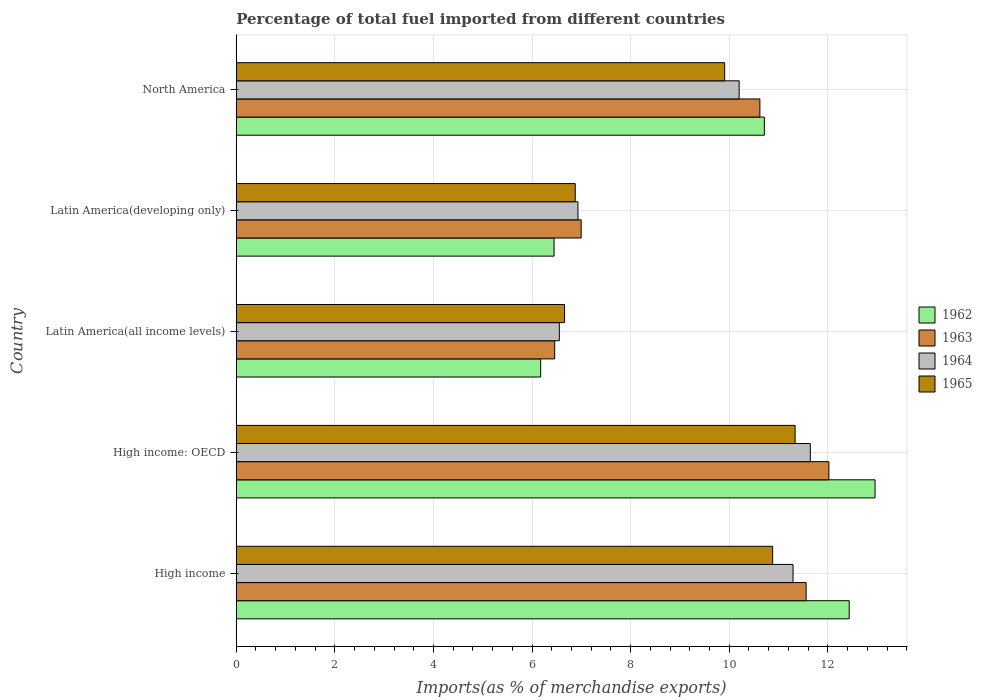How many different coloured bars are there?
Your answer should be very brief. 4. How many bars are there on the 2nd tick from the top?
Provide a short and direct response. 4. How many bars are there on the 1st tick from the bottom?
Provide a succinct answer. 4. In how many cases, is the number of bars for a given country not equal to the number of legend labels?
Offer a very short reply. 0. What is the percentage of imports to different countries in 1964 in North America?
Offer a terse response. 10.2. Across all countries, what is the maximum percentage of imports to different countries in 1965?
Give a very brief answer. 11.34. Across all countries, what is the minimum percentage of imports to different countries in 1962?
Ensure brevity in your answer.  6.17. In which country was the percentage of imports to different countries in 1962 maximum?
Give a very brief answer. High income: OECD. In which country was the percentage of imports to different countries in 1964 minimum?
Your answer should be very brief. Latin America(all income levels). What is the total percentage of imports to different countries in 1962 in the graph?
Keep it short and to the point. 48.72. What is the difference between the percentage of imports to different countries in 1964 in Latin America(developing only) and that in North America?
Make the answer very short. -3.27. What is the difference between the percentage of imports to different countries in 1962 in Latin America(all income levels) and the percentage of imports to different countries in 1965 in High income: OECD?
Your response must be concise. -5.16. What is the average percentage of imports to different countries in 1963 per country?
Provide a succinct answer. 9.53. What is the difference between the percentage of imports to different countries in 1965 and percentage of imports to different countries in 1964 in Latin America(all income levels)?
Keep it short and to the point. 0.11. In how many countries, is the percentage of imports to different countries in 1964 greater than 11.6 %?
Your answer should be compact. 1. What is the ratio of the percentage of imports to different countries in 1964 in High income to that in Latin America(developing only)?
Give a very brief answer. 1.63. Is the difference between the percentage of imports to different countries in 1965 in Latin America(all income levels) and North America greater than the difference between the percentage of imports to different countries in 1964 in Latin America(all income levels) and North America?
Offer a terse response. Yes. What is the difference between the highest and the second highest percentage of imports to different countries in 1962?
Offer a very short reply. 0.52. What is the difference between the highest and the lowest percentage of imports to different countries in 1962?
Provide a short and direct response. 6.78. In how many countries, is the percentage of imports to different countries in 1963 greater than the average percentage of imports to different countries in 1963 taken over all countries?
Keep it short and to the point. 3. Is the sum of the percentage of imports to different countries in 1964 in High income and Latin America(developing only) greater than the maximum percentage of imports to different countries in 1963 across all countries?
Your answer should be very brief. Yes. Is it the case that in every country, the sum of the percentage of imports to different countries in 1964 and percentage of imports to different countries in 1962 is greater than the sum of percentage of imports to different countries in 1965 and percentage of imports to different countries in 1963?
Ensure brevity in your answer.  No. What does the 4th bar from the top in Latin America(all income levels) represents?
Ensure brevity in your answer.  1962. Is it the case that in every country, the sum of the percentage of imports to different countries in 1963 and percentage of imports to different countries in 1962 is greater than the percentage of imports to different countries in 1964?
Your answer should be very brief. Yes. How many bars are there?
Your answer should be compact. 20. Are all the bars in the graph horizontal?
Offer a terse response. Yes. How many countries are there in the graph?
Make the answer very short. 5. Are the values on the major ticks of X-axis written in scientific E-notation?
Offer a terse response. No. Does the graph contain any zero values?
Ensure brevity in your answer.  No. Does the graph contain grids?
Ensure brevity in your answer.  Yes. Where does the legend appear in the graph?
Offer a very short reply. Center right. How many legend labels are there?
Make the answer very short. 4. What is the title of the graph?
Offer a very short reply. Percentage of total fuel imported from different countries. What is the label or title of the X-axis?
Give a very brief answer. Imports(as % of merchandise exports). What is the Imports(as % of merchandise exports) in 1962 in High income?
Offer a very short reply. 12.43. What is the Imports(as % of merchandise exports) of 1963 in High income?
Keep it short and to the point. 11.56. What is the Imports(as % of merchandise exports) in 1964 in High income?
Provide a succinct answer. 11.29. What is the Imports(as % of merchandise exports) in 1965 in High income?
Give a very brief answer. 10.88. What is the Imports(as % of merchandise exports) in 1962 in High income: OECD?
Your answer should be very brief. 12.96. What is the Imports(as % of merchandise exports) of 1963 in High income: OECD?
Provide a short and direct response. 12.02. What is the Imports(as % of merchandise exports) in 1964 in High income: OECD?
Offer a terse response. 11.64. What is the Imports(as % of merchandise exports) in 1965 in High income: OECD?
Provide a short and direct response. 11.34. What is the Imports(as % of merchandise exports) of 1962 in Latin America(all income levels)?
Ensure brevity in your answer.  6.17. What is the Imports(as % of merchandise exports) in 1963 in Latin America(all income levels)?
Your answer should be compact. 6.46. What is the Imports(as % of merchandise exports) in 1964 in Latin America(all income levels)?
Ensure brevity in your answer.  6.55. What is the Imports(as % of merchandise exports) in 1965 in Latin America(all income levels)?
Your answer should be compact. 6.66. What is the Imports(as % of merchandise exports) of 1962 in Latin America(developing only)?
Ensure brevity in your answer.  6.45. What is the Imports(as % of merchandise exports) of 1963 in Latin America(developing only)?
Offer a very short reply. 7. What is the Imports(as % of merchandise exports) in 1964 in Latin America(developing only)?
Make the answer very short. 6.93. What is the Imports(as % of merchandise exports) of 1965 in Latin America(developing only)?
Provide a succinct answer. 6.88. What is the Imports(as % of merchandise exports) of 1962 in North America?
Offer a very short reply. 10.71. What is the Imports(as % of merchandise exports) of 1963 in North America?
Offer a very short reply. 10.62. What is the Imports(as % of merchandise exports) of 1964 in North America?
Give a very brief answer. 10.2. What is the Imports(as % of merchandise exports) in 1965 in North America?
Offer a very short reply. 9.91. Across all countries, what is the maximum Imports(as % of merchandise exports) in 1962?
Ensure brevity in your answer.  12.96. Across all countries, what is the maximum Imports(as % of merchandise exports) in 1963?
Provide a succinct answer. 12.02. Across all countries, what is the maximum Imports(as % of merchandise exports) of 1964?
Provide a succinct answer. 11.64. Across all countries, what is the maximum Imports(as % of merchandise exports) of 1965?
Provide a short and direct response. 11.34. Across all countries, what is the minimum Imports(as % of merchandise exports) in 1962?
Give a very brief answer. 6.17. Across all countries, what is the minimum Imports(as % of merchandise exports) of 1963?
Offer a very short reply. 6.46. Across all countries, what is the minimum Imports(as % of merchandise exports) in 1964?
Provide a succinct answer. 6.55. Across all countries, what is the minimum Imports(as % of merchandise exports) in 1965?
Provide a short and direct response. 6.66. What is the total Imports(as % of merchandise exports) of 1962 in the graph?
Provide a short and direct response. 48.72. What is the total Imports(as % of merchandise exports) in 1963 in the graph?
Your answer should be compact. 47.66. What is the total Imports(as % of merchandise exports) in 1964 in the graph?
Provide a short and direct response. 46.62. What is the total Imports(as % of merchandise exports) of 1965 in the graph?
Give a very brief answer. 45.66. What is the difference between the Imports(as % of merchandise exports) of 1962 in High income and that in High income: OECD?
Offer a very short reply. -0.52. What is the difference between the Imports(as % of merchandise exports) of 1963 in High income and that in High income: OECD?
Provide a short and direct response. -0.46. What is the difference between the Imports(as % of merchandise exports) in 1964 in High income and that in High income: OECD?
Offer a very short reply. -0.35. What is the difference between the Imports(as % of merchandise exports) of 1965 in High income and that in High income: OECD?
Keep it short and to the point. -0.46. What is the difference between the Imports(as % of merchandise exports) in 1962 in High income and that in Latin America(all income levels)?
Your answer should be compact. 6.26. What is the difference between the Imports(as % of merchandise exports) of 1963 in High income and that in Latin America(all income levels)?
Provide a succinct answer. 5.1. What is the difference between the Imports(as % of merchandise exports) in 1964 in High income and that in Latin America(all income levels)?
Your response must be concise. 4.74. What is the difference between the Imports(as % of merchandise exports) of 1965 in High income and that in Latin America(all income levels)?
Provide a succinct answer. 4.22. What is the difference between the Imports(as % of merchandise exports) in 1962 in High income and that in Latin America(developing only)?
Give a very brief answer. 5.99. What is the difference between the Imports(as % of merchandise exports) in 1963 in High income and that in Latin America(developing only)?
Give a very brief answer. 4.56. What is the difference between the Imports(as % of merchandise exports) in 1964 in High income and that in Latin America(developing only)?
Provide a short and direct response. 4.36. What is the difference between the Imports(as % of merchandise exports) of 1965 in High income and that in Latin America(developing only)?
Give a very brief answer. 4. What is the difference between the Imports(as % of merchandise exports) of 1962 in High income and that in North America?
Offer a terse response. 1.72. What is the difference between the Imports(as % of merchandise exports) in 1963 in High income and that in North America?
Offer a very short reply. 0.94. What is the difference between the Imports(as % of merchandise exports) of 1964 in High income and that in North America?
Provide a short and direct response. 1.09. What is the difference between the Imports(as % of merchandise exports) of 1965 in High income and that in North America?
Your response must be concise. 0.97. What is the difference between the Imports(as % of merchandise exports) of 1962 in High income: OECD and that in Latin America(all income levels)?
Provide a short and direct response. 6.78. What is the difference between the Imports(as % of merchandise exports) of 1963 in High income: OECD and that in Latin America(all income levels)?
Provide a short and direct response. 5.56. What is the difference between the Imports(as % of merchandise exports) of 1964 in High income: OECD and that in Latin America(all income levels)?
Offer a very short reply. 5.09. What is the difference between the Imports(as % of merchandise exports) of 1965 in High income: OECD and that in Latin America(all income levels)?
Provide a succinct answer. 4.68. What is the difference between the Imports(as % of merchandise exports) in 1962 in High income: OECD and that in Latin America(developing only)?
Your answer should be compact. 6.51. What is the difference between the Imports(as % of merchandise exports) in 1963 in High income: OECD and that in Latin America(developing only)?
Offer a terse response. 5.02. What is the difference between the Imports(as % of merchandise exports) of 1964 in High income: OECD and that in Latin America(developing only)?
Your answer should be very brief. 4.71. What is the difference between the Imports(as % of merchandise exports) in 1965 in High income: OECD and that in Latin America(developing only)?
Offer a terse response. 4.46. What is the difference between the Imports(as % of merchandise exports) in 1962 in High income: OECD and that in North America?
Provide a short and direct response. 2.25. What is the difference between the Imports(as % of merchandise exports) in 1963 in High income: OECD and that in North America?
Provide a short and direct response. 1.4. What is the difference between the Imports(as % of merchandise exports) of 1964 in High income: OECD and that in North America?
Ensure brevity in your answer.  1.44. What is the difference between the Imports(as % of merchandise exports) in 1965 in High income: OECD and that in North America?
Ensure brevity in your answer.  1.43. What is the difference between the Imports(as % of merchandise exports) of 1962 in Latin America(all income levels) and that in Latin America(developing only)?
Your answer should be compact. -0.27. What is the difference between the Imports(as % of merchandise exports) in 1963 in Latin America(all income levels) and that in Latin America(developing only)?
Your response must be concise. -0.54. What is the difference between the Imports(as % of merchandise exports) in 1964 in Latin America(all income levels) and that in Latin America(developing only)?
Provide a short and direct response. -0.38. What is the difference between the Imports(as % of merchandise exports) of 1965 in Latin America(all income levels) and that in Latin America(developing only)?
Provide a succinct answer. -0.22. What is the difference between the Imports(as % of merchandise exports) in 1962 in Latin America(all income levels) and that in North America?
Give a very brief answer. -4.54. What is the difference between the Imports(as % of merchandise exports) in 1963 in Latin America(all income levels) and that in North America?
Offer a terse response. -4.16. What is the difference between the Imports(as % of merchandise exports) in 1964 in Latin America(all income levels) and that in North America?
Your response must be concise. -3.65. What is the difference between the Imports(as % of merchandise exports) in 1965 in Latin America(all income levels) and that in North America?
Offer a very short reply. -3.25. What is the difference between the Imports(as % of merchandise exports) in 1962 in Latin America(developing only) and that in North America?
Ensure brevity in your answer.  -4.27. What is the difference between the Imports(as % of merchandise exports) in 1963 in Latin America(developing only) and that in North America?
Your answer should be compact. -3.63. What is the difference between the Imports(as % of merchandise exports) in 1964 in Latin America(developing only) and that in North America?
Provide a short and direct response. -3.27. What is the difference between the Imports(as % of merchandise exports) in 1965 in Latin America(developing only) and that in North America?
Your answer should be compact. -3.03. What is the difference between the Imports(as % of merchandise exports) in 1962 in High income and the Imports(as % of merchandise exports) in 1963 in High income: OECD?
Offer a very short reply. 0.41. What is the difference between the Imports(as % of merchandise exports) of 1962 in High income and the Imports(as % of merchandise exports) of 1964 in High income: OECD?
Keep it short and to the point. 0.79. What is the difference between the Imports(as % of merchandise exports) of 1962 in High income and the Imports(as % of merchandise exports) of 1965 in High income: OECD?
Provide a succinct answer. 1.1. What is the difference between the Imports(as % of merchandise exports) in 1963 in High income and the Imports(as % of merchandise exports) in 1964 in High income: OECD?
Provide a short and direct response. -0.09. What is the difference between the Imports(as % of merchandise exports) in 1963 in High income and the Imports(as % of merchandise exports) in 1965 in High income: OECD?
Offer a terse response. 0.22. What is the difference between the Imports(as % of merchandise exports) of 1964 in High income and the Imports(as % of merchandise exports) of 1965 in High income: OECD?
Give a very brief answer. -0.04. What is the difference between the Imports(as % of merchandise exports) of 1962 in High income and the Imports(as % of merchandise exports) of 1963 in Latin America(all income levels)?
Provide a short and direct response. 5.97. What is the difference between the Imports(as % of merchandise exports) in 1962 in High income and the Imports(as % of merchandise exports) in 1964 in Latin America(all income levels)?
Your response must be concise. 5.88. What is the difference between the Imports(as % of merchandise exports) in 1962 in High income and the Imports(as % of merchandise exports) in 1965 in Latin America(all income levels)?
Offer a terse response. 5.77. What is the difference between the Imports(as % of merchandise exports) in 1963 in High income and the Imports(as % of merchandise exports) in 1964 in Latin America(all income levels)?
Your answer should be compact. 5.01. What is the difference between the Imports(as % of merchandise exports) of 1963 in High income and the Imports(as % of merchandise exports) of 1965 in Latin America(all income levels)?
Provide a short and direct response. 4.9. What is the difference between the Imports(as % of merchandise exports) in 1964 in High income and the Imports(as % of merchandise exports) in 1965 in Latin America(all income levels)?
Your answer should be very brief. 4.63. What is the difference between the Imports(as % of merchandise exports) of 1962 in High income and the Imports(as % of merchandise exports) of 1963 in Latin America(developing only)?
Ensure brevity in your answer.  5.44. What is the difference between the Imports(as % of merchandise exports) of 1962 in High income and the Imports(as % of merchandise exports) of 1964 in Latin America(developing only)?
Keep it short and to the point. 5.5. What is the difference between the Imports(as % of merchandise exports) of 1962 in High income and the Imports(as % of merchandise exports) of 1965 in Latin America(developing only)?
Ensure brevity in your answer.  5.56. What is the difference between the Imports(as % of merchandise exports) of 1963 in High income and the Imports(as % of merchandise exports) of 1964 in Latin America(developing only)?
Your answer should be very brief. 4.63. What is the difference between the Imports(as % of merchandise exports) of 1963 in High income and the Imports(as % of merchandise exports) of 1965 in Latin America(developing only)?
Ensure brevity in your answer.  4.68. What is the difference between the Imports(as % of merchandise exports) of 1964 in High income and the Imports(as % of merchandise exports) of 1965 in Latin America(developing only)?
Your answer should be compact. 4.42. What is the difference between the Imports(as % of merchandise exports) of 1962 in High income and the Imports(as % of merchandise exports) of 1963 in North America?
Provide a succinct answer. 1.81. What is the difference between the Imports(as % of merchandise exports) in 1962 in High income and the Imports(as % of merchandise exports) in 1964 in North America?
Your response must be concise. 2.23. What is the difference between the Imports(as % of merchandise exports) of 1962 in High income and the Imports(as % of merchandise exports) of 1965 in North America?
Provide a short and direct response. 2.53. What is the difference between the Imports(as % of merchandise exports) of 1963 in High income and the Imports(as % of merchandise exports) of 1964 in North America?
Provide a short and direct response. 1.36. What is the difference between the Imports(as % of merchandise exports) in 1963 in High income and the Imports(as % of merchandise exports) in 1965 in North America?
Provide a succinct answer. 1.65. What is the difference between the Imports(as % of merchandise exports) in 1964 in High income and the Imports(as % of merchandise exports) in 1965 in North America?
Give a very brief answer. 1.39. What is the difference between the Imports(as % of merchandise exports) of 1962 in High income: OECD and the Imports(as % of merchandise exports) of 1963 in Latin America(all income levels)?
Keep it short and to the point. 6.5. What is the difference between the Imports(as % of merchandise exports) of 1962 in High income: OECD and the Imports(as % of merchandise exports) of 1964 in Latin America(all income levels)?
Your response must be concise. 6.4. What is the difference between the Imports(as % of merchandise exports) in 1962 in High income: OECD and the Imports(as % of merchandise exports) in 1965 in Latin America(all income levels)?
Give a very brief answer. 6.3. What is the difference between the Imports(as % of merchandise exports) in 1963 in High income: OECD and the Imports(as % of merchandise exports) in 1964 in Latin America(all income levels)?
Make the answer very short. 5.47. What is the difference between the Imports(as % of merchandise exports) in 1963 in High income: OECD and the Imports(as % of merchandise exports) in 1965 in Latin America(all income levels)?
Keep it short and to the point. 5.36. What is the difference between the Imports(as % of merchandise exports) in 1964 in High income: OECD and the Imports(as % of merchandise exports) in 1965 in Latin America(all income levels)?
Your answer should be compact. 4.98. What is the difference between the Imports(as % of merchandise exports) of 1962 in High income: OECD and the Imports(as % of merchandise exports) of 1963 in Latin America(developing only)?
Make the answer very short. 5.96. What is the difference between the Imports(as % of merchandise exports) of 1962 in High income: OECD and the Imports(as % of merchandise exports) of 1964 in Latin America(developing only)?
Keep it short and to the point. 6.03. What is the difference between the Imports(as % of merchandise exports) in 1962 in High income: OECD and the Imports(as % of merchandise exports) in 1965 in Latin America(developing only)?
Ensure brevity in your answer.  6.08. What is the difference between the Imports(as % of merchandise exports) of 1963 in High income: OECD and the Imports(as % of merchandise exports) of 1964 in Latin America(developing only)?
Your response must be concise. 5.09. What is the difference between the Imports(as % of merchandise exports) of 1963 in High income: OECD and the Imports(as % of merchandise exports) of 1965 in Latin America(developing only)?
Your answer should be very brief. 5.15. What is the difference between the Imports(as % of merchandise exports) in 1964 in High income: OECD and the Imports(as % of merchandise exports) in 1965 in Latin America(developing only)?
Your answer should be very brief. 4.77. What is the difference between the Imports(as % of merchandise exports) of 1962 in High income: OECD and the Imports(as % of merchandise exports) of 1963 in North America?
Give a very brief answer. 2.34. What is the difference between the Imports(as % of merchandise exports) in 1962 in High income: OECD and the Imports(as % of merchandise exports) in 1964 in North America?
Give a very brief answer. 2.76. What is the difference between the Imports(as % of merchandise exports) in 1962 in High income: OECD and the Imports(as % of merchandise exports) in 1965 in North America?
Offer a terse response. 3.05. What is the difference between the Imports(as % of merchandise exports) in 1963 in High income: OECD and the Imports(as % of merchandise exports) in 1964 in North America?
Provide a succinct answer. 1.82. What is the difference between the Imports(as % of merchandise exports) of 1963 in High income: OECD and the Imports(as % of merchandise exports) of 1965 in North America?
Give a very brief answer. 2.11. What is the difference between the Imports(as % of merchandise exports) in 1964 in High income: OECD and the Imports(as % of merchandise exports) in 1965 in North America?
Make the answer very short. 1.74. What is the difference between the Imports(as % of merchandise exports) of 1962 in Latin America(all income levels) and the Imports(as % of merchandise exports) of 1963 in Latin America(developing only)?
Provide a succinct answer. -0.82. What is the difference between the Imports(as % of merchandise exports) of 1962 in Latin America(all income levels) and the Imports(as % of merchandise exports) of 1964 in Latin America(developing only)?
Your answer should be compact. -0.76. What is the difference between the Imports(as % of merchandise exports) of 1962 in Latin America(all income levels) and the Imports(as % of merchandise exports) of 1965 in Latin America(developing only)?
Provide a succinct answer. -0.7. What is the difference between the Imports(as % of merchandise exports) of 1963 in Latin America(all income levels) and the Imports(as % of merchandise exports) of 1964 in Latin America(developing only)?
Provide a short and direct response. -0.47. What is the difference between the Imports(as % of merchandise exports) in 1963 in Latin America(all income levels) and the Imports(as % of merchandise exports) in 1965 in Latin America(developing only)?
Offer a terse response. -0.42. What is the difference between the Imports(as % of merchandise exports) of 1964 in Latin America(all income levels) and the Imports(as % of merchandise exports) of 1965 in Latin America(developing only)?
Your answer should be compact. -0.32. What is the difference between the Imports(as % of merchandise exports) in 1962 in Latin America(all income levels) and the Imports(as % of merchandise exports) in 1963 in North America?
Offer a very short reply. -4.45. What is the difference between the Imports(as % of merchandise exports) of 1962 in Latin America(all income levels) and the Imports(as % of merchandise exports) of 1964 in North America?
Ensure brevity in your answer.  -4.03. What is the difference between the Imports(as % of merchandise exports) of 1962 in Latin America(all income levels) and the Imports(as % of merchandise exports) of 1965 in North America?
Offer a very short reply. -3.73. What is the difference between the Imports(as % of merchandise exports) in 1963 in Latin America(all income levels) and the Imports(as % of merchandise exports) in 1964 in North America?
Make the answer very short. -3.74. What is the difference between the Imports(as % of merchandise exports) in 1963 in Latin America(all income levels) and the Imports(as % of merchandise exports) in 1965 in North America?
Your answer should be very brief. -3.45. What is the difference between the Imports(as % of merchandise exports) in 1964 in Latin America(all income levels) and the Imports(as % of merchandise exports) in 1965 in North America?
Provide a short and direct response. -3.35. What is the difference between the Imports(as % of merchandise exports) of 1962 in Latin America(developing only) and the Imports(as % of merchandise exports) of 1963 in North America?
Provide a succinct answer. -4.17. What is the difference between the Imports(as % of merchandise exports) in 1962 in Latin America(developing only) and the Imports(as % of merchandise exports) in 1964 in North America?
Provide a short and direct response. -3.75. What is the difference between the Imports(as % of merchandise exports) in 1962 in Latin America(developing only) and the Imports(as % of merchandise exports) in 1965 in North America?
Offer a very short reply. -3.46. What is the difference between the Imports(as % of merchandise exports) in 1963 in Latin America(developing only) and the Imports(as % of merchandise exports) in 1964 in North America?
Give a very brief answer. -3.2. What is the difference between the Imports(as % of merchandise exports) in 1963 in Latin America(developing only) and the Imports(as % of merchandise exports) in 1965 in North America?
Offer a very short reply. -2.91. What is the difference between the Imports(as % of merchandise exports) in 1964 in Latin America(developing only) and the Imports(as % of merchandise exports) in 1965 in North America?
Make the answer very short. -2.98. What is the average Imports(as % of merchandise exports) in 1962 per country?
Make the answer very short. 9.74. What is the average Imports(as % of merchandise exports) in 1963 per country?
Provide a short and direct response. 9.53. What is the average Imports(as % of merchandise exports) of 1964 per country?
Your answer should be very brief. 9.32. What is the average Imports(as % of merchandise exports) of 1965 per country?
Provide a short and direct response. 9.13. What is the difference between the Imports(as % of merchandise exports) of 1962 and Imports(as % of merchandise exports) of 1963 in High income?
Your answer should be compact. 0.87. What is the difference between the Imports(as % of merchandise exports) of 1962 and Imports(as % of merchandise exports) of 1964 in High income?
Ensure brevity in your answer.  1.14. What is the difference between the Imports(as % of merchandise exports) in 1962 and Imports(as % of merchandise exports) in 1965 in High income?
Give a very brief answer. 1.55. What is the difference between the Imports(as % of merchandise exports) in 1963 and Imports(as % of merchandise exports) in 1964 in High income?
Ensure brevity in your answer.  0.27. What is the difference between the Imports(as % of merchandise exports) in 1963 and Imports(as % of merchandise exports) in 1965 in High income?
Offer a very short reply. 0.68. What is the difference between the Imports(as % of merchandise exports) of 1964 and Imports(as % of merchandise exports) of 1965 in High income?
Your response must be concise. 0.41. What is the difference between the Imports(as % of merchandise exports) in 1962 and Imports(as % of merchandise exports) in 1963 in High income: OECD?
Offer a terse response. 0.94. What is the difference between the Imports(as % of merchandise exports) in 1962 and Imports(as % of merchandise exports) in 1964 in High income: OECD?
Your answer should be compact. 1.31. What is the difference between the Imports(as % of merchandise exports) of 1962 and Imports(as % of merchandise exports) of 1965 in High income: OECD?
Offer a terse response. 1.62. What is the difference between the Imports(as % of merchandise exports) of 1963 and Imports(as % of merchandise exports) of 1964 in High income: OECD?
Ensure brevity in your answer.  0.38. What is the difference between the Imports(as % of merchandise exports) of 1963 and Imports(as % of merchandise exports) of 1965 in High income: OECD?
Your answer should be very brief. 0.69. What is the difference between the Imports(as % of merchandise exports) of 1964 and Imports(as % of merchandise exports) of 1965 in High income: OECD?
Your response must be concise. 0.31. What is the difference between the Imports(as % of merchandise exports) in 1962 and Imports(as % of merchandise exports) in 1963 in Latin America(all income levels)?
Your answer should be compact. -0.28. What is the difference between the Imports(as % of merchandise exports) of 1962 and Imports(as % of merchandise exports) of 1964 in Latin America(all income levels)?
Offer a very short reply. -0.38. What is the difference between the Imports(as % of merchandise exports) in 1962 and Imports(as % of merchandise exports) in 1965 in Latin America(all income levels)?
Your answer should be very brief. -0.48. What is the difference between the Imports(as % of merchandise exports) in 1963 and Imports(as % of merchandise exports) in 1964 in Latin America(all income levels)?
Make the answer very short. -0.09. What is the difference between the Imports(as % of merchandise exports) of 1963 and Imports(as % of merchandise exports) of 1965 in Latin America(all income levels)?
Give a very brief answer. -0.2. What is the difference between the Imports(as % of merchandise exports) of 1964 and Imports(as % of merchandise exports) of 1965 in Latin America(all income levels)?
Provide a short and direct response. -0.11. What is the difference between the Imports(as % of merchandise exports) of 1962 and Imports(as % of merchandise exports) of 1963 in Latin America(developing only)?
Your answer should be very brief. -0.55. What is the difference between the Imports(as % of merchandise exports) of 1962 and Imports(as % of merchandise exports) of 1964 in Latin America(developing only)?
Provide a short and direct response. -0.48. What is the difference between the Imports(as % of merchandise exports) of 1962 and Imports(as % of merchandise exports) of 1965 in Latin America(developing only)?
Offer a terse response. -0.43. What is the difference between the Imports(as % of merchandise exports) in 1963 and Imports(as % of merchandise exports) in 1964 in Latin America(developing only)?
Ensure brevity in your answer.  0.07. What is the difference between the Imports(as % of merchandise exports) in 1963 and Imports(as % of merchandise exports) in 1965 in Latin America(developing only)?
Provide a succinct answer. 0.12. What is the difference between the Imports(as % of merchandise exports) of 1964 and Imports(as % of merchandise exports) of 1965 in Latin America(developing only)?
Your response must be concise. 0.06. What is the difference between the Imports(as % of merchandise exports) in 1962 and Imports(as % of merchandise exports) in 1963 in North America?
Offer a very short reply. 0.09. What is the difference between the Imports(as % of merchandise exports) in 1962 and Imports(as % of merchandise exports) in 1964 in North America?
Provide a short and direct response. 0.51. What is the difference between the Imports(as % of merchandise exports) in 1962 and Imports(as % of merchandise exports) in 1965 in North America?
Your response must be concise. 0.8. What is the difference between the Imports(as % of merchandise exports) of 1963 and Imports(as % of merchandise exports) of 1964 in North America?
Offer a terse response. 0.42. What is the difference between the Imports(as % of merchandise exports) of 1963 and Imports(as % of merchandise exports) of 1965 in North America?
Your answer should be very brief. 0.71. What is the difference between the Imports(as % of merchandise exports) in 1964 and Imports(as % of merchandise exports) in 1965 in North America?
Offer a very short reply. 0.29. What is the ratio of the Imports(as % of merchandise exports) of 1962 in High income to that in High income: OECD?
Your answer should be very brief. 0.96. What is the ratio of the Imports(as % of merchandise exports) in 1963 in High income to that in High income: OECD?
Make the answer very short. 0.96. What is the ratio of the Imports(as % of merchandise exports) of 1964 in High income to that in High income: OECD?
Make the answer very short. 0.97. What is the ratio of the Imports(as % of merchandise exports) in 1965 in High income to that in High income: OECD?
Your response must be concise. 0.96. What is the ratio of the Imports(as % of merchandise exports) in 1962 in High income to that in Latin America(all income levels)?
Keep it short and to the point. 2.01. What is the ratio of the Imports(as % of merchandise exports) of 1963 in High income to that in Latin America(all income levels)?
Make the answer very short. 1.79. What is the ratio of the Imports(as % of merchandise exports) in 1964 in High income to that in Latin America(all income levels)?
Make the answer very short. 1.72. What is the ratio of the Imports(as % of merchandise exports) in 1965 in High income to that in Latin America(all income levels)?
Your response must be concise. 1.63. What is the ratio of the Imports(as % of merchandise exports) of 1962 in High income to that in Latin America(developing only)?
Offer a terse response. 1.93. What is the ratio of the Imports(as % of merchandise exports) of 1963 in High income to that in Latin America(developing only)?
Offer a terse response. 1.65. What is the ratio of the Imports(as % of merchandise exports) in 1964 in High income to that in Latin America(developing only)?
Make the answer very short. 1.63. What is the ratio of the Imports(as % of merchandise exports) in 1965 in High income to that in Latin America(developing only)?
Your answer should be compact. 1.58. What is the ratio of the Imports(as % of merchandise exports) in 1962 in High income to that in North America?
Make the answer very short. 1.16. What is the ratio of the Imports(as % of merchandise exports) of 1963 in High income to that in North America?
Offer a terse response. 1.09. What is the ratio of the Imports(as % of merchandise exports) of 1964 in High income to that in North America?
Your answer should be very brief. 1.11. What is the ratio of the Imports(as % of merchandise exports) of 1965 in High income to that in North America?
Your answer should be compact. 1.1. What is the ratio of the Imports(as % of merchandise exports) of 1962 in High income: OECD to that in Latin America(all income levels)?
Your answer should be compact. 2.1. What is the ratio of the Imports(as % of merchandise exports) in 1963 in High income: OECD to that in Latin America(all income levels)?
Provide a succinct answer. 1.86. What is the ratio of the Imports(as % of merchandise exports) of 1964 in High income: OECD to that in Latin America(all income levels)?
Your answer should be compact. 1.78. What is the ratio of the Imports(as % of merchandise exports) in 1965 in High income: OECD to that in Latin America(all income levels)?
Provide a succinct answer. 1.7. What is the ratio of the Imports(as % of merchandise exports) of 1962 in High income: OECD to that in Latin America(developing only)?
Ensure brevity in your answer.  2.01. What is the ratio of the Imports(as % of merchandise exports) in 1963 in High income: OECD to that in Latin America(developing only)?
Your answer should be very brief. 1.72. What is the ratio of the Imports(as % of merchandise exports) in 1964 in High income: OECD to that in Latin America(developing only)?
Your answer should be very brief. 1.68. What is the ratio of the Imports(as % of merchandise exports) of 1965 in High income: OECD to that in Latin America(developing only)?
Keep it short and to the point. 1.65. What is the ratio of the Imports(as % of merchandise exports) of 1962 in High income: OECD to that in North America?
Provide a succinct answer. 1.21. What is the ratio of the Imports(as % of merchandise exports) of 1963 in High income: OECD to that in North America?
Your response must be concise. 1.13. What is the ratio of the Imports(as % of merchandise exports) in 1964 in High income: OECD to that in North America?
Provide a succinct answer. 1.14. What is the ratio of the Imports(as % of merchandise exports) of 1965 in High income: OECD to that in North America?
Ensure brevity in your answer.  1.14. What is the ratio of the Imports(as % of merchandise exports) in 1962 in Latin America(all income levels) to that in Latin America(developing only)?
Ensure brevity in your answer.  0.96. What is the ratio of the Imports(as % of merchandise exports) of 1963 in Latin America(all income levels) to that in Latin America(developing only)?
Ensure brevity in your answer.  0.92. What is the ratio of the Imports(as % of merchandise exports) of 1964 in Latin America(all income levels) to that in Latin America(developing only)?
Make the answer very short. 0.95. What is the ratio of the Imports(as % of merchandise exports) in 1965 in Latin America(all income levels) to that in Latin America(developing only)?
Provide a succinct answer. 0.97. What is the ratio of the Imports(as % of merchandise exports) of 1962 in Latin America(all income levels) to that in North America?
Offer a very short reply. 0.58. What is the ratio of the Imports(as % of merchandise exports) of 1963 in Latin America(all income levels) to that in North America?
Offer a very short reply. 0.61. What is the ratio of the Imports(as % of merchandise exports) in 1964 in Latin America(all income levels) to that in North America?
Keep it short and to the point. 0.64. What is the ratio of the Imports(as % of merchandise exports) of 1965 in Latin America(all income levels) to that in North America?
Your answer should be compact. 0.67. What is the ratio of the Imports(as % of merchandise exports) in 1962 in Latin America(developing only) to that in North America?
Ensure brevity in your answer.  0.6. What is the ratio of the Imports(as % of merchandise exports) in 1963 in Latin America(developing only) to that in North America?
Provide a short and direct response. 0.66. What is the ratio of the Imports(as % of merchandise exports) in 1964 in Latin America(developing only) to that in North America?
Your answer should be very brief. 0.68. What is the ratio of the Imports(as % of merchandise exports) of 1965 in Latin America(developing only) to that in North America?
Provide a short and direct response. 0.69. What is the difference between the highest and the second highest Imports(as % of merchandise exports) in 1962?
Your response must be concise. 0.52. What is the difference between the highest and the second highest Imports(as % of merchandise exports) in 1963?
Give a very brief answer. 0.46. What is the difference between the highest and the second highest Imports(as % of merchandise exports) of 1964?
Make the answer very short. 0.35. What is the difference between the highest and the second highest Imports(as % of merchandise exports) in 1965?
Offer a very short reply. 0.46. What is the difference between the highest and the lowest Imports(as % of merchandise exports) in 1962?
Keep it short and to the point. 6.78. What is the difference between the highest and the lowest Imports(as % of merchandise exports) of 1963?
Provide a short and direct response. 5.56. What is the difference between the highest and the lowest Imports(as % of merchandise exports) in 1964?
Make the answer very short. 5.09. What is the difference between the highest and the lowest Imports(as % of merchandise exports) in 1965?
Provide a succinct answer. 4.68. 